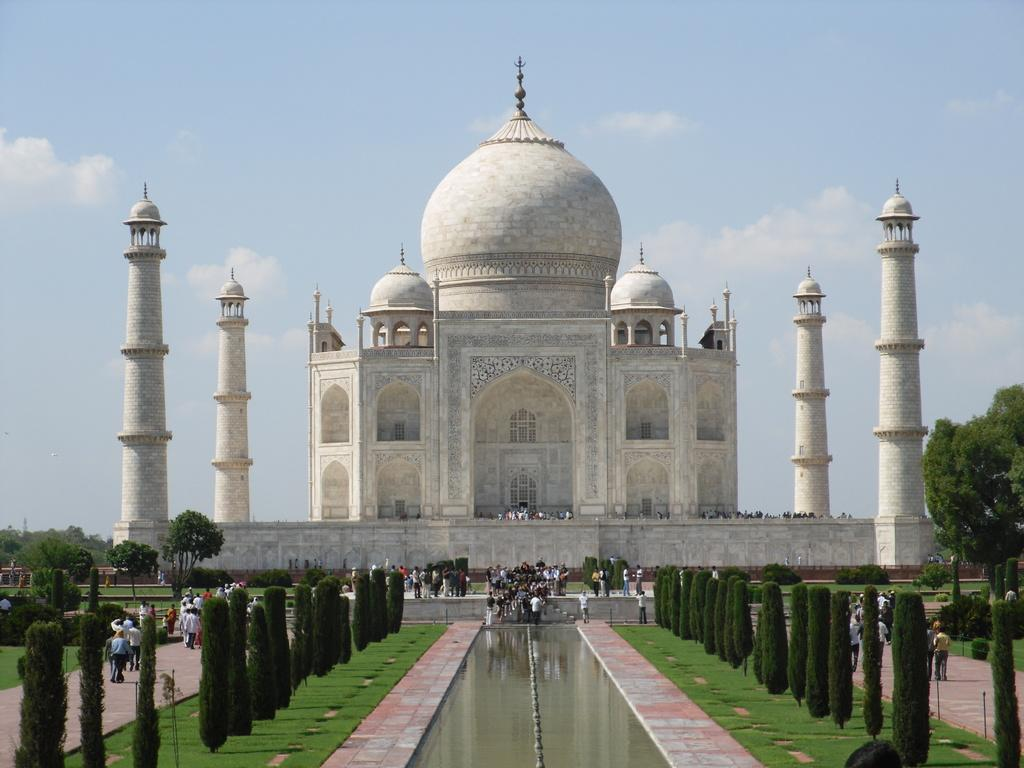What famous landmark is visible in the image? The Taj Mahal is visible in the image. What type of vegetation can be seen in the image? There are trees in the image. What natural element is present in the image? There is water in the image. Are there any human figures in the image? Yes, there are people in the image. How would you describe the color of the sky in the image? The sky is white and blue in color. Is there any blood visible on the Taj Mahal in the image? No, there is no blood visible on the Taj Mahal in the image. Are there any people experiencing pain in the image? There is no indication of pain or any related emotions in the image. 